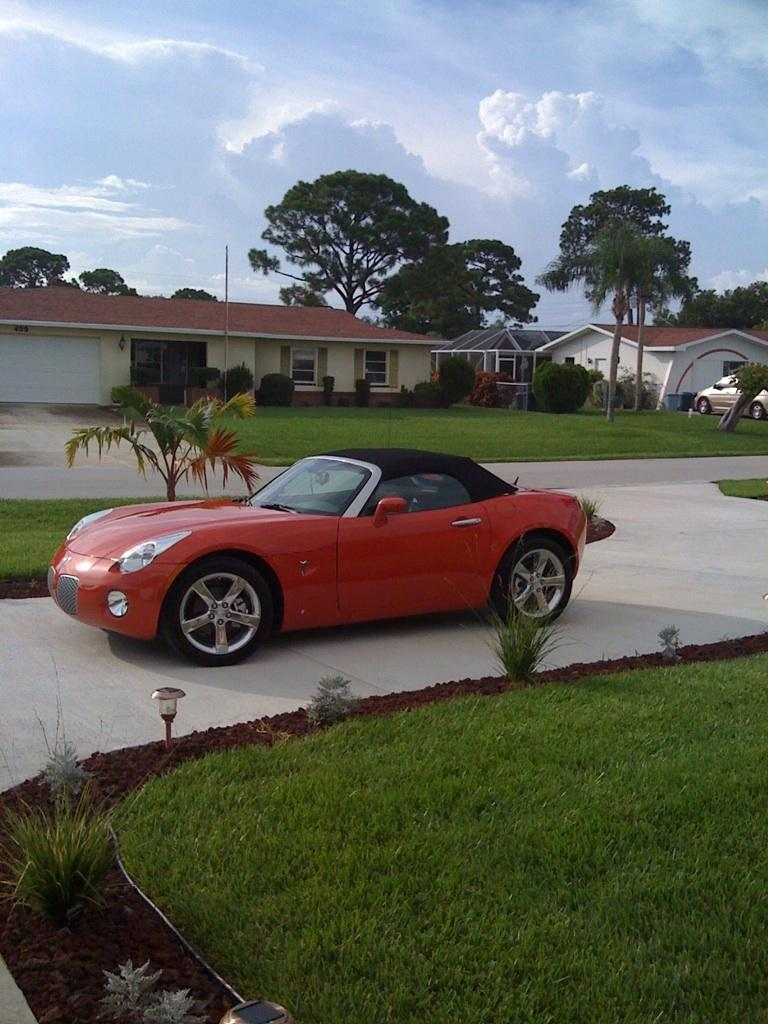What type of vehicles can be seen in the image? There are cars in the image. What type of vegetation is present in the image? There are trees in the image. What type of structures are visible in the image? There are houses with windows in the image. What type of ground cover is visible in the image? There is grass visible in the image. What can be seen in the background of the image? The sky with clouds is visible in the background of the image. What type of trousers are hanging from the trees in the image? There are no trousers hanging from the trees in the image; only cars, trees, houses, grass, and the sky with clouds are present. What part of the brain can be seen in the image? There is no brain visible in the image; it features cars, trees, houses, grass, and the sky with clouds. 